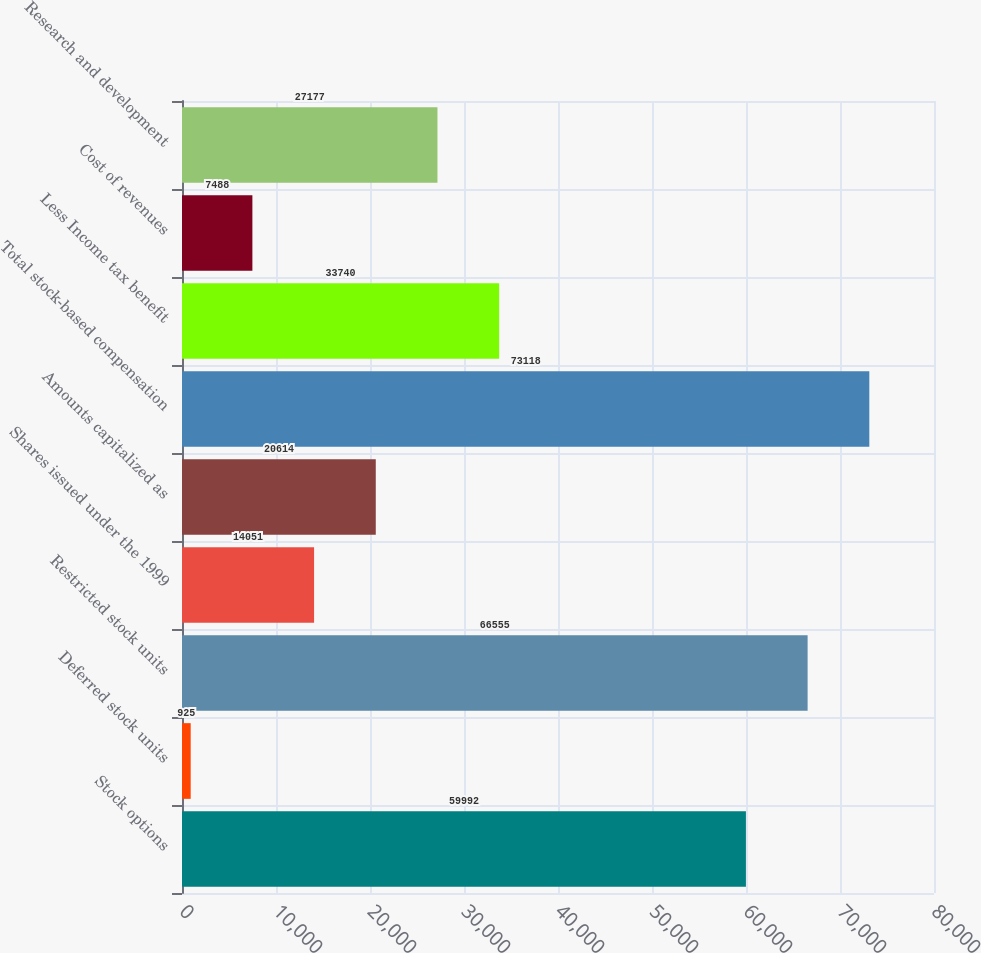Convert chart. <chart><loc_0><loc_0><loc_500><loc_500><bar_chart><fcel>Stock options<fcel>Deferred stock units<fcel>Restricted stock units<fcel>Shares issued under the 1999<fcel>Amounts capitalized as<fcel>Total stock-based compensation<fcel>Less Income tax benefit<fcel>Cost of revenues<fcel>Research and development<nl><fcel>59992<fcel>925<fcel>66555<fcel>14051<fcel>20614<fcel>73118<fcel>33740<fcel>7488<fcel>27177<nl></chart> 